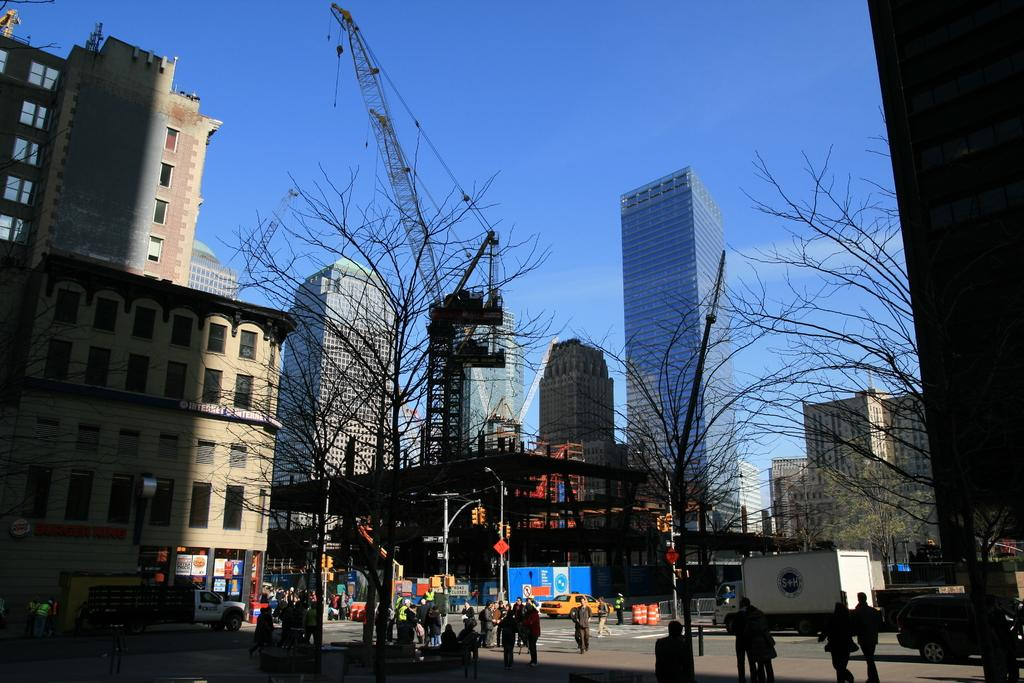What type of structures can be seen in the image? There are buildings in the image. Are there any people visible in the image? Yes, there are people in front of the buildings. What else can be seen on the ground in the image? Vehicles are present on the road. What type of natural elements are present in the image? There are trees in the image. Can you hear the people in the image sneezing? There is no auditory information provided in the image, so it is not possible to determine if the people are sneezing or not. 